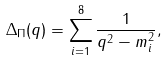Convert formula to latex. <formula><loc_0><loc_0><loc_500><loc_500>\Delta _ { \Pi } ( q ) = \sum _ { i = 1 } ^ { 8 } \frac { 1 } { q ^ { 2 } - m _ { i } ^ { 2 } } ,</formula> 